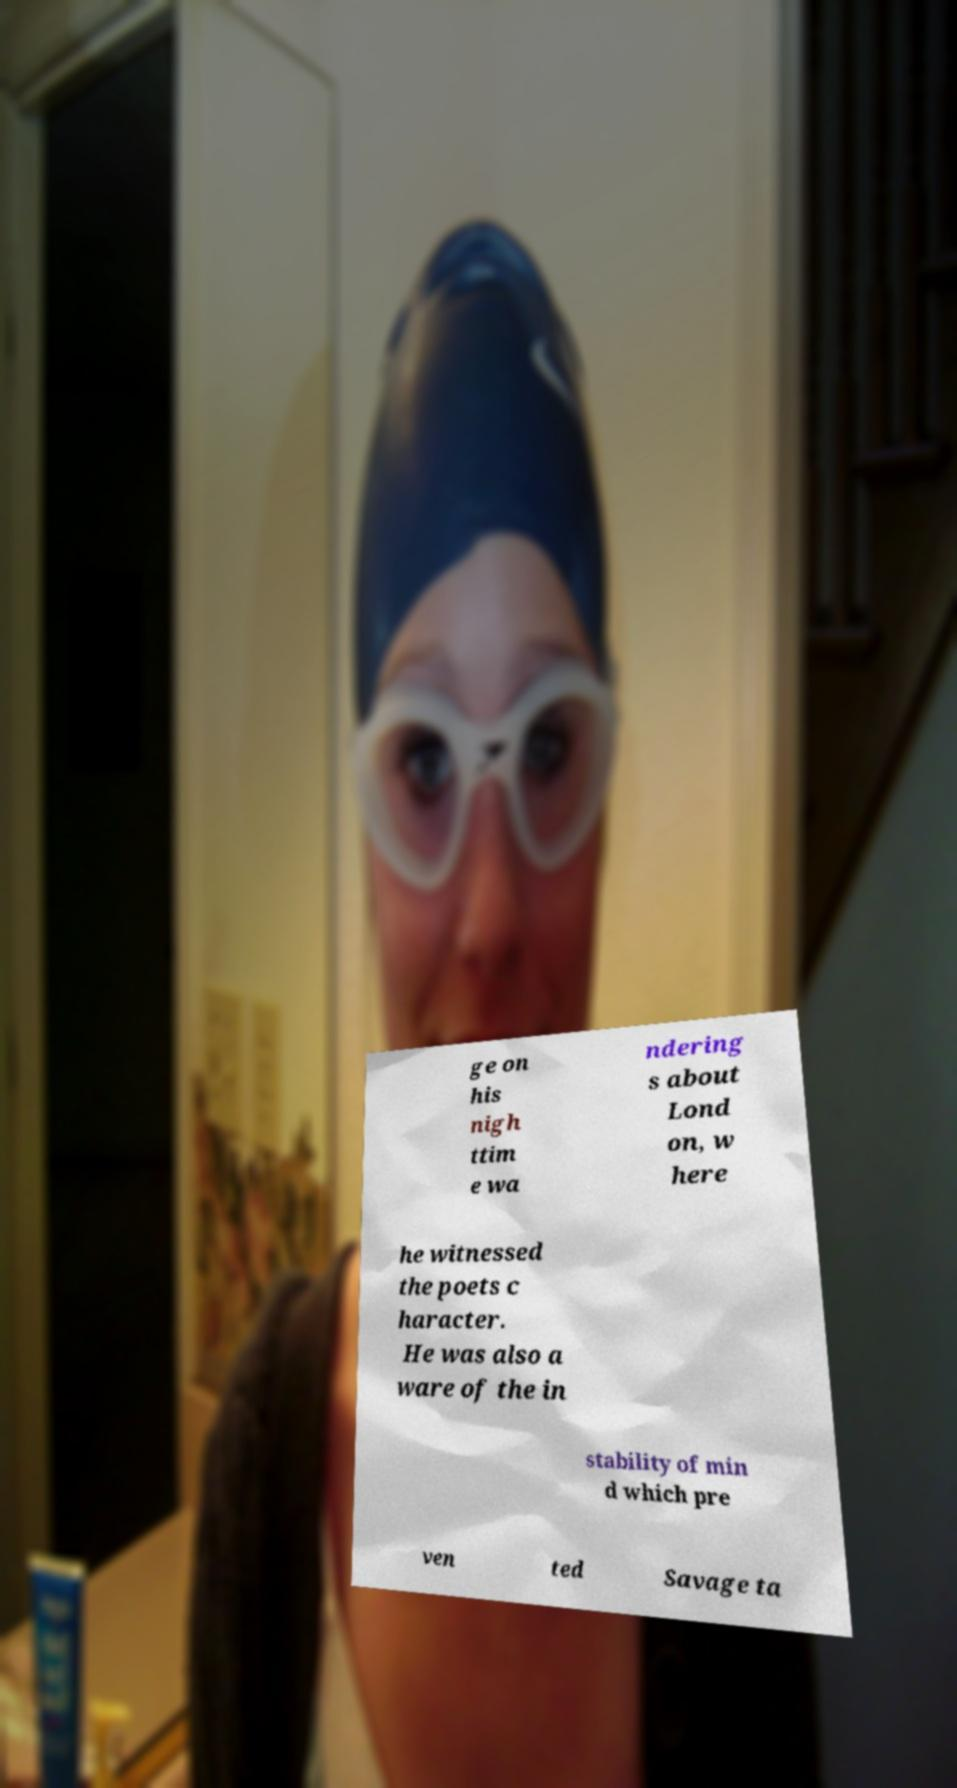There's text embedded in this image that I need extracted. Can you transcribe it verbatim? ge on his nigh ttim e wa ndering s about Lond on, w here he witnessed the poets c haracter. He was also a ware of the in stability of min d which pre ven ted Savage ta 